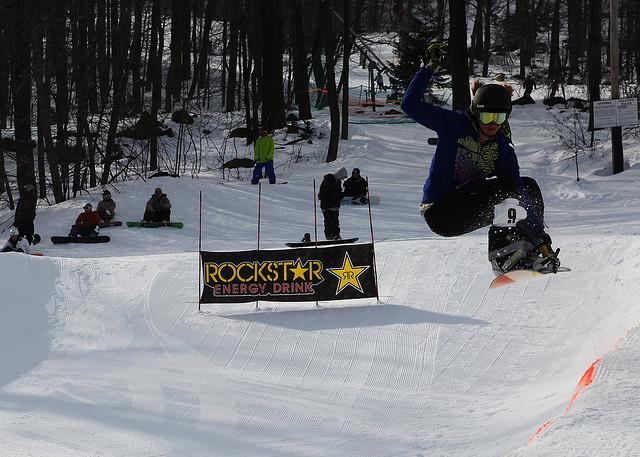What is the skier holding in hands?
Short answer required. Poles. What soda is advertised?
Concise answer only. Rockstar. Is Rockstar the sponsor of this event?
Keep it brief. Yes. What does the board say?
Write a very short answer. Rockstar. What does the sign say?
Concise answer only. Rockstar energy drink. Who is sponsoring this event?
Quick response, please. Rockstar energy drink. What covers the ground?
Answer briefly. Snow. 